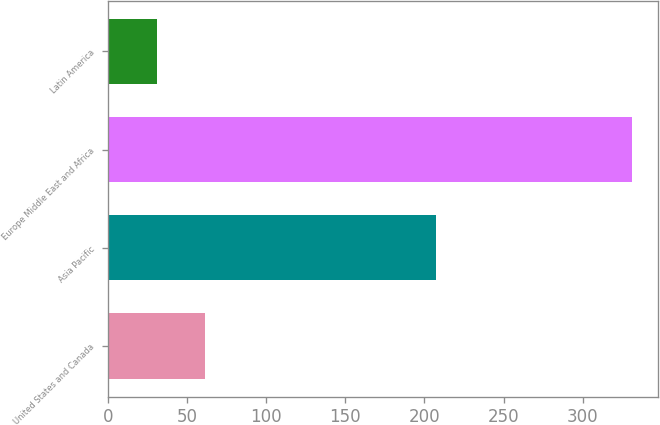<chart> <loc_0><loc_0><loc_500><loc_500><bar_chart><fcel>United States and Canada<fcel>Asia Pacific<fcel>Europe Middle East and Africa<fcel>Latin America<nl><fcel>61<fcel>207<fcel>331<fcel>31<nl></chart> 